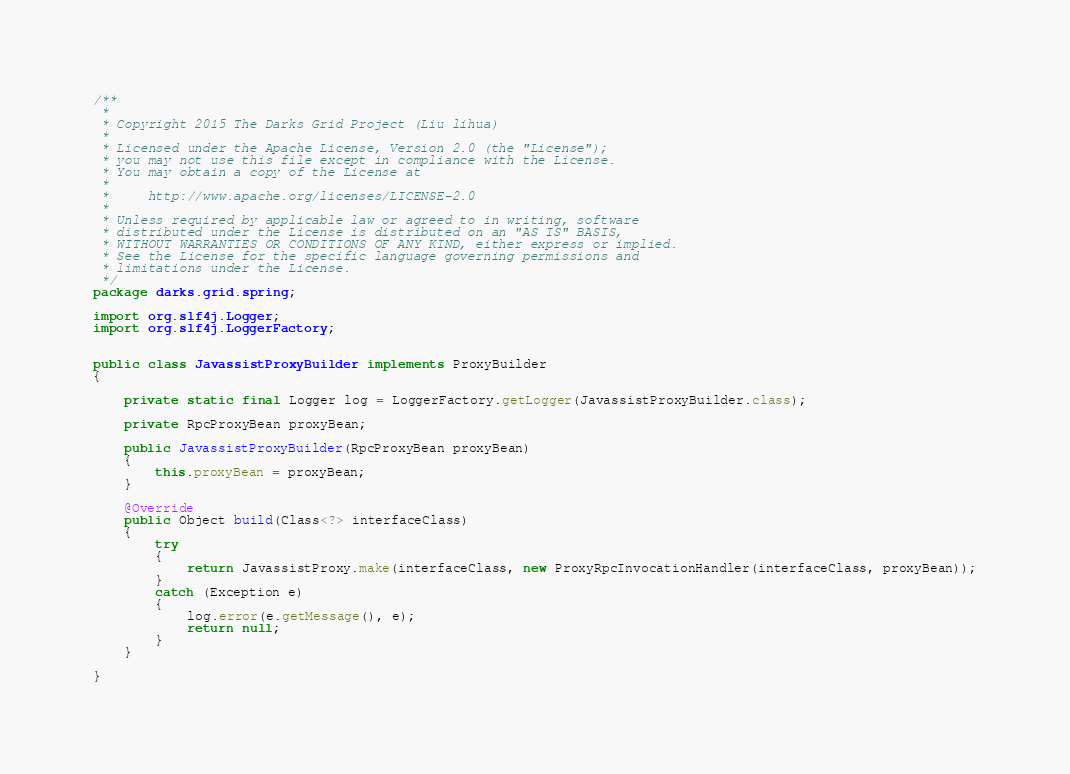Convert code to text. <code><loc_0><loc_0><loc_500><loc_500><_Java_>/**
 * 
 * Copyright 2015 The Darks Grid Project (Liu lihua)
 *
 * Licensed under the Apache License, Version 2.0 (the "License");
 * you may not use this file except in compliance with the License.
 * You may obtain a copy of the License at
 *
 *     http://www.apache.org/licenses/LICENSE-2.0
 *
 * Unless required by applicable law or agreed to in writing, software
 * distributed under the License is distributed on an "AS IS" BASIS,
 * WITHOUT WARRANTIES OR CONDITIONS OF ANY KIND, either express or implied.
 * See the License for the specific language governing permissions and
 * limitations under the License.
 */
package darks.grid.spring;

import org.slf4j.Logger;
import org.slf4j.LoggerFactory;


public class JavassistProxyBuilder implements ProxyBuilder
{

	private static final Logger log = LoggerFactory.getLogger(JavassistProxyBuilder.class);
	
	private RpcProxyBean proxyBean;
	
	public JavassistProxyBuilder(RpcProxyBean proxyBean)
	{
		this.proxyBean = proxyBean;
	}
    
    @Override
    public Object build(Class<?> interfaceClass)
    {
        try
		{
			return JavassistProxy.make(interfaceClass, new ProxyRpcInvocationHandler(interfaceClass, proxyBean));
		}
		catch (Exception e)
		{
			log.error(e.getMessage(), e);
			return null;
		}
    }
    
}
</code> 